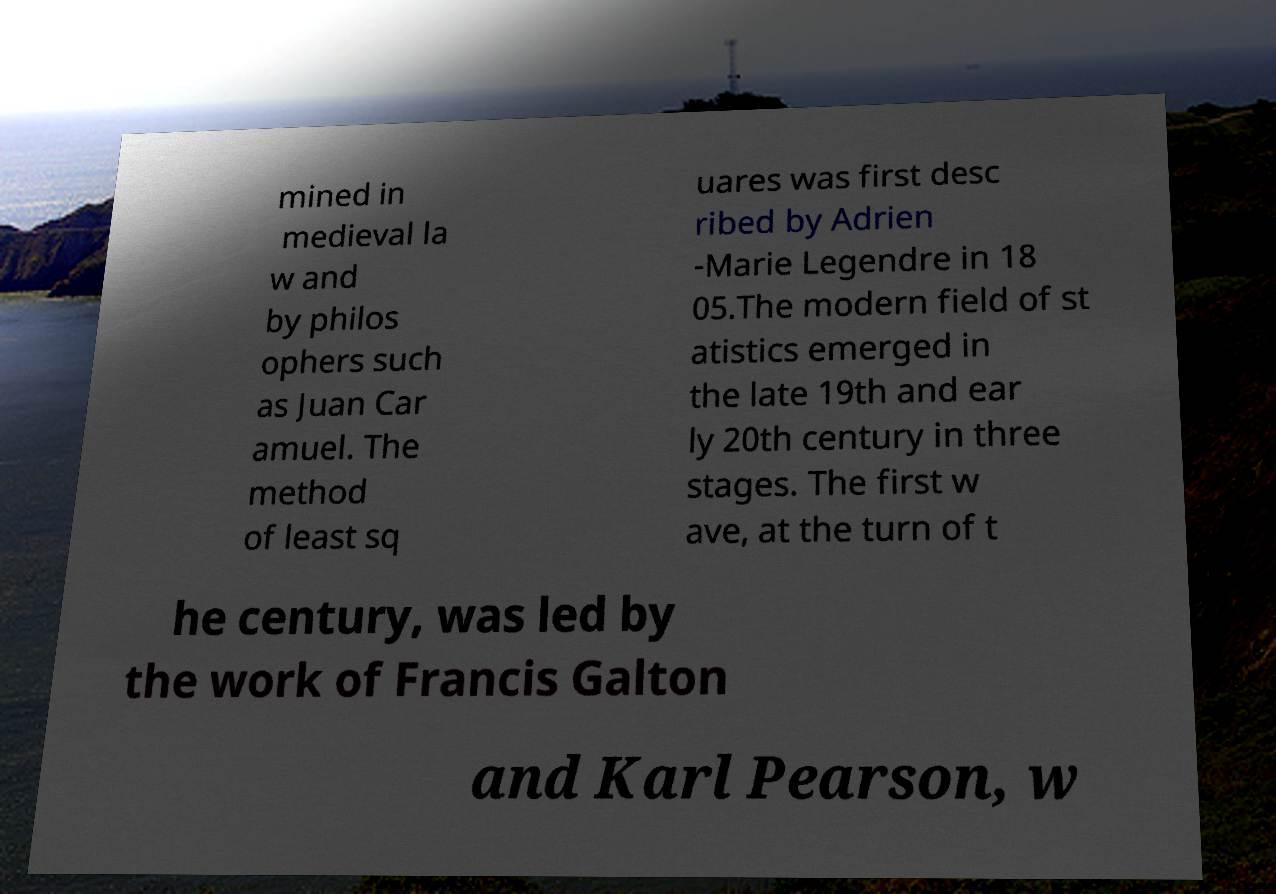Can you accurately transcribe the text from the provided image for me? mined in medieval la w and by philos ophers such as Juan Car amuel. The method of least sq uares was first desc ribed by Adrien -Marie Legendre in 18 05.The modern field of st atistics emerged in the late 19th and ear ly 20th century in three stages. The first w ave, at the turn of t he century, was led by the work of Francis Galton and Karl Pearson, w 